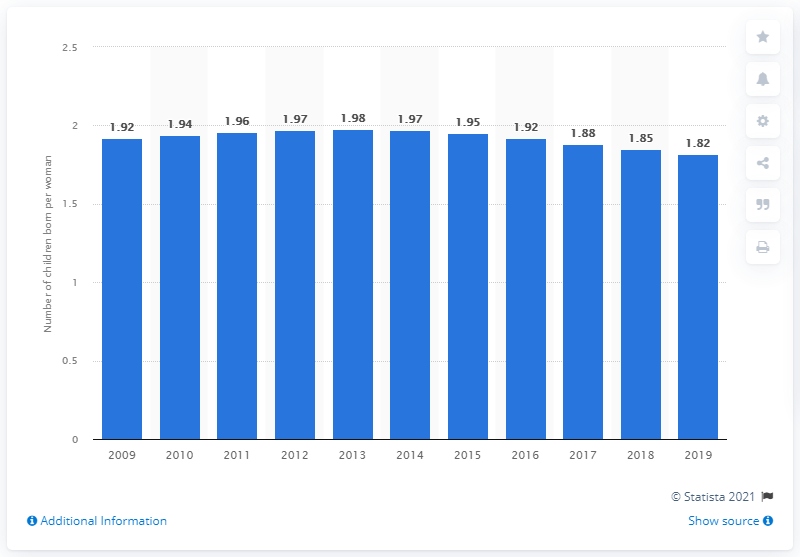Point out several critical features in this image. In 2019, the fertility rate in Brunei Darussalam was 1.82. 